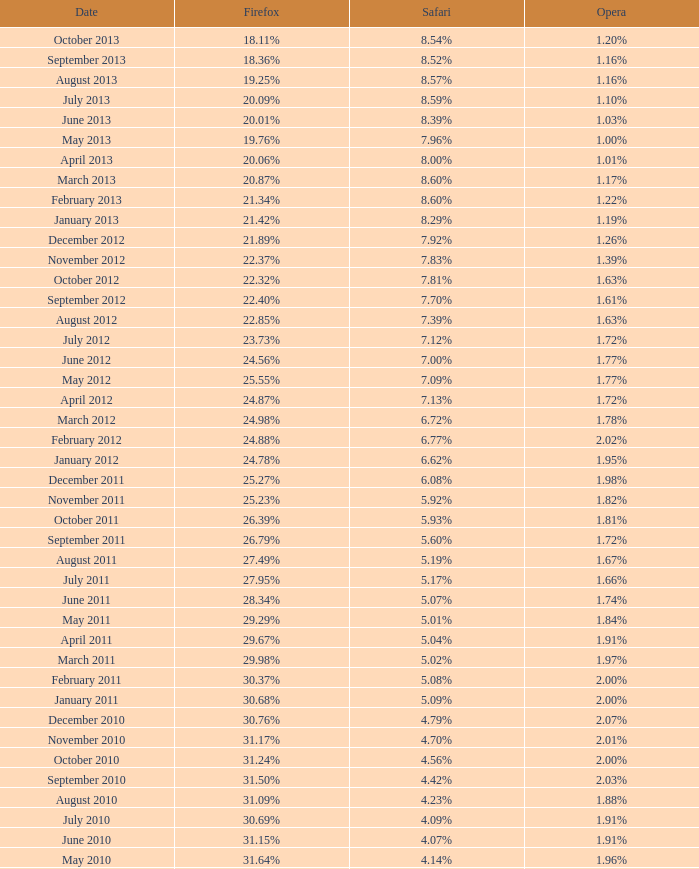What was the percentage of browser usage for internet explorer in april 2009? 61.88%. 